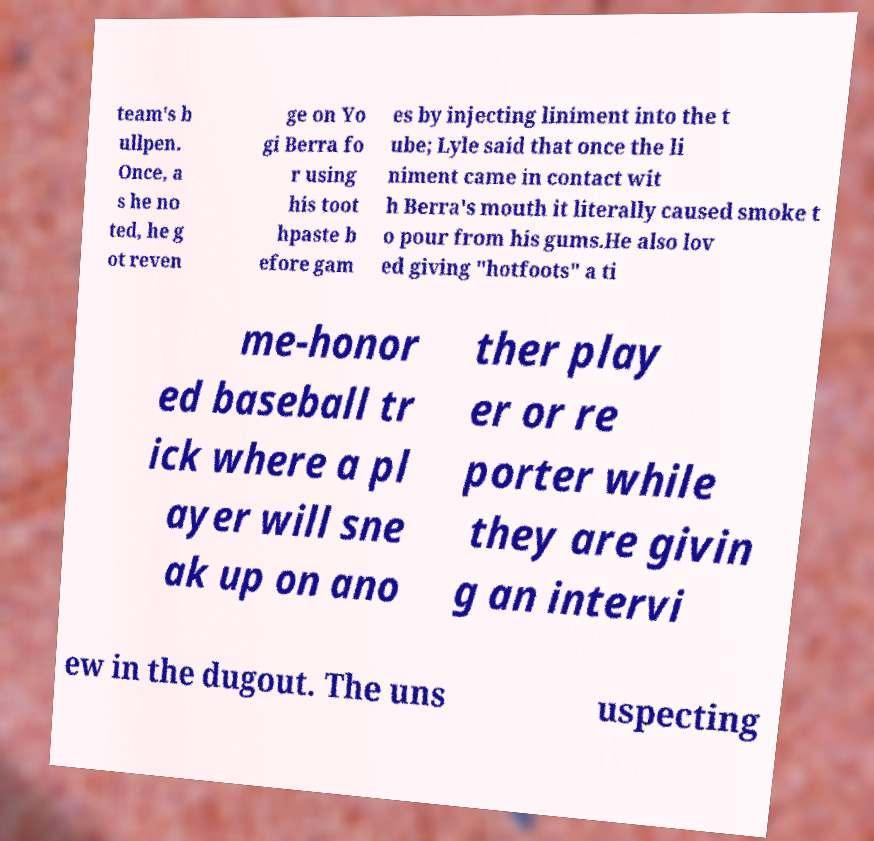I need the written content from this picture converted into text. Can you do that? team's b ullpen. Once, a s he no ted, he g ot reven ge on Yo gi Berra fo r using his toot hpaste b efore gam es by injecting liniment into the t ube; Lyle said that once the li niment came in contact wit h Berra's mouth it literally caused smoke t o pour from his gums.He also lov ed giving "hotfoots" a ti me-honor ed baseball tr ick where a pl ayer will sne ak up on ano ther play er or re porter while they are givin g an intervi ew in the dugout. The uns uspecting 